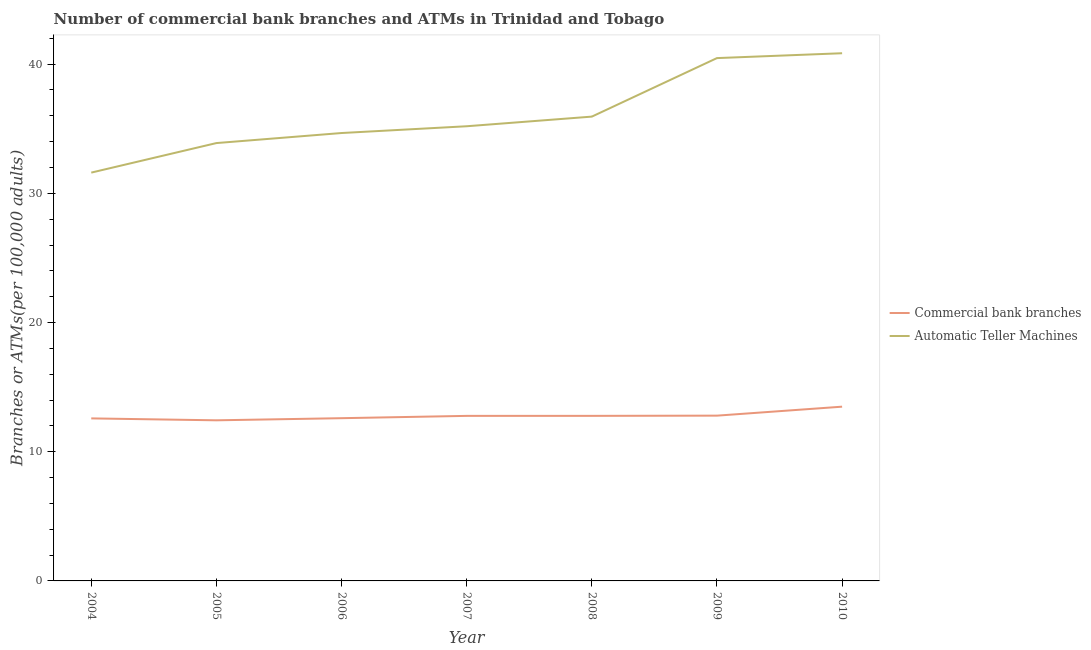How many different coloured lines are there?
Keep it short and to the point. 2. Is the number of lines equal to the number of legend labels?
Keep it short and to the point. Yes. What is the number of commercal bank branches in 2008?
Your answer should be compact. 12.78. Across all years, what is the maximum number of commercal bank branches?
Ensure brevity in your answer.  13.49. Across all years, what is the minimum number of atms?
Provide a short and direct response. 31.6. In which year was the number of atms minimum?
Provide a succinct answer. 2004. What is the total number of commercal bank branches in the graph?
Your answer should be very brief. 89.44. What is the difference between the number of atms in 2007 and that in 2009?
Provide a succinct answer. -5.28. What is the difference between the number of atms in 2005 and the number of commercal bank branches in 2006?
Ensure brevity in your answer.  21.29. What is the average number of commercal bank branches per year?
Make the answer very short. 12.78. In the year 2004, what is the difference between the number of commercal bank branches and number of atms?
Your answer should be compact. -19.02. What is the ratio of the number of commercal bank branches in 2004 to that in 2006?
Provide a succinct answer. 1. Is the number of atms in 2005 less than that in 2009?
Provide a short and direct response. Yes. What is the difference between the highest and the second highest number of commercal bank branches?
Provide a short and direct response. 0.69. What is the difference between the highest and the lowest number of commercal bank branches?
Offer a very short reply. 1.06. In how many years, is the number of atms greater than the average number of atms taken over all years?
Your answer should be very brief. 2. Is the sum of the number of atms in 2008 and 2010 greater than the maximum number of commercal bank branches across all years?
Your answer should be very brief. Yes. Is the number of commercal bank branches strictly less than the number of atms over the years?
Keep it short and to the point. Yes. What is the difference between two consecutive major ticks on the Y-axis?
Your answer should be very brief. 10. Are the values on the major ticks of Y-axis written in scientific E-notation?
Your answer should be very brief. No. Does the graph contain grids?
Offer a terse response. No. How many legend labels are there?
Ensure brevity in your answer.  2. How are the legend labels stacked?
Provide a short and direct response. Vertical. What is the title of the graph?
Keep it short and to the point. Number of commercial bank branches and ATMs in Trinidad and Tobago. Does "Depositors" appear as one of the legend labels in the graph?
Your response must be concise. No. What is the label or title of the X-axis?
Your answer should be compact. Year. What is the label or title of the Y-axis?
Ensure brevity in your answer.  Branches or ATMs(per 100,0 adults). What is the Branches or ATMs(per 100,000 adults) of Commercial bank branches in 2004?
Make the answer very short. 12.58. What is the Branches or ATMs(per 100,000 adults) of Automatic Teller Machines in 2004?
Make the answer very short. 31.6. What is the Branches or ATMs(per 100,000 adults) in Commercial bank branches in 2005?
Your answer should be compact. 12.43. What is the Branches or ATMs(per 100,000 adults) of Automatic Teller Machines in 2005?
Your answer should be compact. 33.89. What is the Branches or ATMs(per 100,000 adults) in Commercial bank branches in 2006?
Your answer should be compact. 12.6. What is the Branches or ATMs(per 100,000 adults) in Automatic Teller Machines in 2006?
Offer a terse response. 34.67. What is the Branches or ATMs(per 100,000 adults) of Commercial bank branches in 2007?
Make the answer very short. 12.77. What is the Branches or ATMs(per 100,000 adults) in Automatic Teller Machines in 2007?
Make the answer very short. 35.19. What is the Branches or ATMs(per 100,000 adults) of Commercial bank branches in 2008?
Offer a very short reply. 12.78. What is the Branches or ATMs(per 100,000 adults) in Automatic Teller Machines in 2008?
Keep it short and to the point. 35.94. What is the Branches or ATMs(per 100,000 adults) in Commercial bank branches in 2009?
Provide a succinct answer. 12.79. What is the Branches or ATMs(per 100,000 adults) of Automatic Teller Machines in 2009?
Give a very brief answer. 40.47. What is the Branches or ATMs(per 100,000 adults) in Commercial bank branches in 2010?
Provide a short and direct response. 13.49. What is the Branches or ATMs(per 100,000 adults) in Automatic Teller Machines in 2010?
Your answer should be very brief. 40.84. Across all years, what is the maximum Branches or ATMs(per 100,000 adults) in Commercial bank branches?
Keep it short and to the point. 13.49. Across all years, what is the maximum Branches or ATMs(per 100,000 adults) in Automatic Teller Machines?
Provide a short and direct response. 40.84. Across all years, what is the minimum Branches or ATMs(per 100,000 adults) in Commercial bank branches?
Offer a terse response. 12.43. Across all years, what is the minimum Branches or ATMs(per 100,000 adults) of Automatic Teller Machines?
Offer a terse response. 31.6. What is the total Branches or ATMs(per 100,000 adults) in Commercial bank branches in the graph?
Your answer should be compact. 89.44. What is the total Branches or ATMs(per 100,000 adults) in Automatic Teller Machines in the graph?
Ensure brevity in your answer.  252.6. What is the difference between the Branches or ATMs(per 100,000 adults) of Commercial bank branches in 2004 and that in 2005?
Your response must be concise. 0.15. What is the difference between the Branches or ATMs(per 100,000 adults) of Automatic Teller Machines in 2004 and that in 2005?
Offer a terse response. -2.29. What is the difference between the Branches or ATMs(per 100,000 adults) of Commercial bank branches in 2004 and that in 2006?
Give a very brief answer. -0.02. What is the difference between the Branches or ATMs(per 100,000 adults) in Automatic Teller Machines in 2004 and that in 2006?
Offer a terse response. -3.06. What is the difference between the Branches or ATMs(per 100,000 adults) in Commercial bank branches in 2004 and that in 2007?
Your response must be concise. -0.2. What is the difference between the Branches or ATMs(per 100,000 adults) of Automatic Teller Machines in 2004 and that in 2007?
Keep it short and to the point. -3.59. What is the difference between the Branches or ATMs(per 100,000 adults) of Commercial bank branches in 2004 and that in 2008?
Make the answer very short. -0.2. What is the difference between the Branches or ATMs(per 100,000 adults) in Automatic Teller Machines in 2004 and that in 2008?
Your response must be concise. -4.33. What is the difference between the Branches or ATMs(per 100,000 adults) of Commercial bank branches in 2004 and that in 2009?
Provide a short and direct response. -0.21. What is the difference between the Branches or ATMs(per 100,000 adults) in Automatic Teller Machines in 2004 and that in 2009?
Offer a very short reply. -8.86. What is the difference between the Branches or ATMs(per 100,000 adults) of Commercial bank branches in 2004 and that in 2010?
Make the answer very short. -0.91. What is the difference between the Branches or ATMs(per 100,000 adults) of Automatic Teller Machines in 2004 and that in 2010?
Your response must be concise. -9.24. What is the difference between the Branches or ATMs(per 100,000 adults) in Commercial bank branches in 2005 and that in 2006?
Provide a short and direct response. -0.16. What is the difference between the Branches or ATMs(per 100,000 adults) in Automatic Teller Machines in 2005 and that in 2006?
Ensure brevity in your answer.  -0.78. What is the difference between the Branches or ATMs(per 100,000 adults) of Commercial bank branches in 2005 and that in 2007?
Offer a terse response. -0.34. What is the difference between the Branches or ATMs(per 100,000 adults) of Automatic Teller Machines in 2005 and that in 2007?
Offer a very short reply. -1.3. What is the difference between the Branches or ATMs(per 100,000 adults) of Commercial bank branches in 2005 and that in 2008?
Your answer should be compact. -0.35. What is the difference between the Branches or ATMs(per 100,000 adults) in Automatic Teller Machines in 2005 and that in 2008?
Give a very brief answer. -2.05. What is the difference between the Branches or ATMs(per 100,000 adults) in Commercial bank branches in 2005 and that in 2009?
Make the answer very short. -0.36. What is the difference between the Branches or ATMs(per 100,000 adults) in Automatic Teller Machines in 2005 and that in 2009?
Give a very brief answer. -6.58. What is the difference between the Branches or ATMs(per 100,000 adults) in Commercial bank branches in 2005 and that in 2010?
Your response must be concise. -1.06. What is the difference between the Branches or ATMs(per 100,000 adults) in Automatic Teller Machines in 2005 and that in 2010?
Ensure brevity in your answer.  -6.95. What is the difference between the Branches or ATMs(per 100,000 adults) in Commercial bank branches in 2006 and that in 2007?
Ensure brevity in your answer.  -0.18. What is the difference between the Branches or ATMs(per 100,000 adults) of Automatic Teller Machines in 2006 and that in 2007?
Ensure brevity in your answer.  -0.52. What is the difference between the Branches or ATMs(per 100,000 adults) in Commercial bank branches in 2006 and that in 2008?
Your answer should be compact. -0.18. What is the difference between the Branches or ATMs(per 100,000 adults) in Automatic Teller Machines in 2006 and that in 2008?
Provide a succinct answer. -1.27. What is the difference between the Branches or ATMs(per 100,000 adults) of Commercial bank branches in 2006 and that in 2009?
Offer a very short reply. -0.2. What is the difference between the Branches or ATMs(per 100,000 adults) of Automatic Teller Machines in 2006 and that in 2009?
Provide a short and direct response. -5.8. What is the difference between the Branches or ATMs(per 100,000 adults) of Commercial bank branches in 2006 and that in 2010?
Offer a very short reply. -0.89. What is the difference between the Branches or ATMs(per 100,000 adults) in Automatic Teller Machines in 2006 and that in 2010?
Offer a terse response. -6.18. What is the difference between the Branches or ATMs(per 100,000 adults) in Commercial bank branches in 2007 and that in 2008?
Provide a short and direct response. -0. What is the difference between the Branches or ATMs(per 100,000 adults) in Automatic Teller Machines in 2007 and that in 2008?
Your answer should be very brief. -0.75. What is the difference between the Branches or ATMs(per 100,000 adults) of Commercial bank branches in 2007 and that in 2009?
Keep it short and to the point. -0.02. What is the difference between the Branches or ATMs(per 100,000 adults) in Automatic Teller Machines in 2007 and that in 2009?
Provide a succinct answer. -5.28. What is the difference between the Branches or ATMs(per 100,000 adults) in Commercial bank branches in 2007 and that in 2010?
Provide a succinct answer. -0.71. What is the difference between the Branches or ATMs(per 100,000 adults) in Automatic Teller Machines in 2007 and that in 2010?
Your response must be concise. -5.65. What is the difference between the Branches or ATMs(per 100,000 adults) in Commercial bank branches in 2008 and that in 2009?
Your answer should be compact. -0.02. What is the difference between the Branches or ATMs(per 100,000 adults) of Automatic Teller Machines in 2008 and that in 2009?
Give a very brief answer. -4.53. What is the difference between the Branches or ATMs(per 100,000 adults) in Commercial bank branches in 2008 and that in 2010?
Your answer should be very brief. -0.71. What is the difference between the Branches or ATMs(per 100,000 adults) of Automatic Teller Machines in 2008 and that in 2010?
Your answer should be compact. -4.91. What is the difference between the Branches or ATMs(per 100,000 adults) in Commercial bank branches in 2009 and that in 2010?
Your answer should be very brief. -0.69. What is the difference between the Branches or ATMs(per 100,000 adults) of Automatic Teller Machines in 2009 and that in 2010?
Give a very brief answer. -0.38. What is the difference between the Branches or ATMs(per 100,000 adults) of Commercial bank branches in 2004 and the Branches or ATMs(per 100,000 adults) of Automatic Teller Machines in 2005?
Your answer should be compact. -21.31. What is the difference between the Branches or ATMs(per 100,000 adults) in Commercial bank branches in 2004 and the Branches or ATMs(per 100,000 adults) in Automatic Teller Machines in 2006?
Provide a succinct answer. -22.09. What is the difference between the Branches or ATMs(per 100,000 adults) of Commercial bank branches in 2004 and the Branches or ATMs(per 100,000 adults) of Automatic Teller Machines in 2007?
Offer a very short reply. -22.61. What is the difference between the Branches or ATMs(per 100,000 adults) of Commercial bank branches in 2004 and the Branches or ATMs(per 100,000 adults) of Automatic Teller Machines in 2008?
Give a very brief answer. -23.36. What is the difference between the Branches or ATMs(per 100,000 adults) in Commercial bank branches in 2004 and the Branches or ATMs(per 100,000 adults) in Automatic Teller Machines in 2009?
Offer a very short reply. -27.89. What is the difference between the Branches or ATMs(per 100,000 adults) of Commercial bank branches in 2004 and the Branches or ATMs(per 100,000 adults) of Automatic Teller Machines in 2010?
Your answer should be very brief. -28.26. What is the difference between the Branches or ATMs(per 100,000 adults) in Commercial bank branches in 2005 and the Branches or ATMs(per 100,000 adults) in Automatic Teller Machines in 2006?
Your answer should be very brief. -22.24. What is the difference between the Branches or ATMs(per 100,000 adults) in Commercial bank branches in 2005 and the Branches or ATMs(per 100,000 adults) in Automatic Teller Machines in 2007?
Offer a terse response. -22.76. What is the difference between the Branches or ATMs(per 100,000 adults) of Commercial bank branches in 2005 and the Branches or ATMs(per 100,000 adults) of Automatic Teller Machines in 2008?
Your response must be concise. -23.51. What is the difference between the Branches or ATMs(per 100,000 adults) of Commercial bank branches in 2005 and the Branches or ATMs(per 100,000 adults) of Automatic Teller Machines in 2009?
Your answer should be very brief. -28.04. What is the difference between the Branches or ATMs(per 100,000 adults) of Commercial bank branches in 2005 and the Branches or ATMs(per 100,000 adults) of Automatic Teller Machines in 2010?
Keep it short and to the point. -28.41. What is the difference between the Branches or ATMs(per 100,000 adults) in Commercial bank branches in 2006 and the Branches or ATMs(per 100,000 adults) in Automatic Teller Machines in 2007?
Provide a succinct answer. -22.6. What is the difference between the Branches or ATMs(per 100,000 adults) in Commercial bank branches in 2006 and the Branches or ATMs(per 100,000 adults) in Automatic Teller Machines in 2008?
Provide a succinct answer. -23.34. What is the difference between the Branches or ATMs(per 100,000 adults) of Commercial bank branches in 2006 and the Branches or ATMs(per 100,000 adults) of Automatic Teller Machines in 2009?
Offer a very short reply. -27.87. What is the difference between the Branches or ATMs(per 100,000 adults) in Commercial bank branches in 2006 and the Branches or ATMs(per 100,000 adults) in Automatic Teller Machines in 2010?
Provide a succinct answer. -28.25. What is the difference between the Branches or ATMs(per 100,000 adults) in Commercial bank branches in 2007 and the Branches or ATMs(per 100,000 adults) in Automatic Teller Machines in 2008?
Ensure brevity in your answer.  -23.16. What is the difference between the Branches or ATMs(per 100,000 adults) in Commercial bank branches in 2007 and the Branches or ATMs(per 100,000 adults) in Automatic Teller Machines in 2009?
Make the answer very short. -27.69. What is the difference between the Branches or ATMs(per 100,000 adults) in Commercial bank branches in 2007 and the Branches or ATMs(per 100,000 adults) in Automatic Teller Machines in 2010?
Your answer should be compact. -28.07. What is the difference between the Branches or ATMs(per 100,000 adults) in Commercial bank branches in 2008 and the Branches or ATMs(per 100,000 adults) in Automatic Teller Machines in 2009?
Give a very brief answer. -27.69. What is the difference between the Branches or ATMs(per 100,000 adults) in Commercial bank branches in 2008 and the Branches or ATMs(per 100,000 adults) in Automatic Teller Machines in 2010?
Provide a succinct answer. -28.07. What is the difference between the Branches or ATMs(per 100,000 adults) of Commercial bank branches in 2009 and the Branches or ATMs(per 100,000 adults) of Automatic Teller Machines in 2010?
Offer a terse response. -28.05. What is the average Branches or ATMs(per 100,000 adults) in Commercial bank branches per year?
Your response must be concise. 12.78. What is the average Branches or ATMs(per 100,000 adults) in Automatic Teller Machines per year?
Your answer should be compact. 36.09. In the year 2004, what is the difference between the Branches or ATMs(per 100,000 adults) in Commercial bank branches and Branches or ATMs(per 100,000 adults) in Automatic Teller Machines?
Your answer should be very brief. -19.02. In the year 2005, what is the difference between the Branches or ATMs(per 100,000 adults) of Commercial bank branches and Branches or ATMs(per 100,000 adults) of Automatic Teller Machines?
Provide a short and direct response. -21.46. In the year 2006, what is the difference between the Branches or ATMs(per 100,000 adults) of Commercial bank branches and Branches or ATMs(per 100,000 adults) of Automatic Teller Machines?
Offer a terse response. -22.07. In the year 2007, what is the difference between the Branches or ATMs(per 100,000 adults) of Commercial bank branches and Branches or ATMs(per 100,000 adults) of Automatic Teller Machines?
Offer a very short reply. -22.42. In the year 2008, what is the difference between the Branches or ATMs(per 100,000 adults) of Commercial bank branches and Branches or ATMs(per 100,000 adults) of Automatic Teller Machines?
Offer a very short reply. -23.16. In the year 2009, what is the difference between the Branches or ATMs(per 100,000 adults) in Commercial bank branches and Branches or ATMs(per 100,000 adults) in Automatic Teller Machines?
Offer a very short reply. -27.67. In the year 2010, what is the difference between the Branches or ATMs(per 100,000 adults) of Commercial bank branches and Branches or ATMs(per 100,000 adults) of Automatic Teller Machines?
Keep it short and to the point. -27.36. What is the ratio of the Branches or ATMs(per 100,000 adults) of Commercial bank branches in 2004 to that in 2005?
Make the answer very short. 1.01. What is the ratio of the Branches or ATMs(per 100,000 adults) in Automatic Teller Machines in 2004 to that in 2005?
Offer a terse response. 0.93. What is the ratio of the Branches or ATMs(per 100,000 adults) of Automatic Teller Machines in 2004 to that in 2006?
Make the answer very short. 0.91. What is the ratio of the Branches or ATMs(per 100,000 adults) in Commercial bank branches in 2004 to that in 2007?
Ensure brevity in your answer.  0.98. What is the ratio of the Branches or ATMs(per 100,000 adults) in Automatic Teller Machines in 2004 to that in 2007?
Keep it short and to the point. 0.9. What is the ratio of the Branches or ATMs(per 100,000 adults) in Commercial bank branches in 2004 to that in 2008?
Provide a succinct answer. 0.98. What is the ratio of the Branches or ATMs(per 100,000 adults) of Automatic Teller Machines in 2004 to that in 2008?
Your response must be concise. 0.88. What is the ratio of the Branches or ATMs(per 100,000 adults) in Commercial bank branches in 2004 to that in 2009?
Provide a succinct answer. 0.98. What is the ratio of the Branches or ATMs(per 100,000 adults) in Automatic Teller Machines in 2004 to that in 2009?
Provide a succinct answer. 0.78. What is the ratio of the Branches or ATMs(per 100,000 adults) in Commercial bank branches in 2004 to that in 2010?
Offer a very short reply. 0.93. What is the ratio of the Branches or ATMs(per 100,000 adults) of Automatic Teller Machines in 2004 to that in 2010?
Keep it short and to the point. 0.77. What is the ratio of the Branches or ATMs(per 100,000 adults) in Commercial bank branches in 2005 to that in 2006?
Provide a short and direct response. 0.99. What is the ratio of the Branches or ATMs(per 100,000 adults) in Automatic Teller Machines in 2005 to that in 2006?
Your answer should be compact. 0.98. What is the ratio of the Branches or ATMs(per 100,000 adults) of Commercial bank branches in 2005 to that in 2007?
Your answer should be very brief. 0.97. What is the ratio of the Branches or ATMs(per 100,000 adults) in Commercial bank branches in 2005 to that in 2008?
Offer a very short reply. 0.97. What is the ratio of the Branches or ATMs(per 100,000 adults) in Automatic Teller Machines in 2005 to that in 2008?
Provide a short and direct response. 0.94. What is the ratio of the Branches or ATMs(per 100,000 adults) in Commercial bank branches in 2005 to that in 2009?
Your answer should be very brief. 0.97. What is the ratio of the Branches or ATMs(per 100,000 adults) in Automatic Teller Machines in 2005 to that in 2009?
Keep it short and to the point. 0.84. What is the ratio of the Branches or ATMs(per 100,000 adults) of Commercial bank branches in 2005 to that in 2010?
Your answer should be very brief. 0.92. What is the ratio of the Branches or ATMs(per 100,000 adults) in Automatic Teller Machines in 2005 to that in 2010?
Your answer should be compact. 0.83. What is the ratio of the Branches or ATMs(per 100,000 adults) in Automatic Teller Machines in 2006 to that in 2007?
Give a very brief answer. 0.99. What is the ratio of the Branches or ATMs(per 100,000 adults) in Commercial bank branches in 2006 to that in 2008?
Offer a terse response. 0.99. What is the ratio of the Branches or ATMs(per 100,000 adults) of Automatic Teller Machines in 2006 to that in 2008?
Your response must be concise. 0.96. What is the ratio of the Branches or ATMs(per 100,000 adults) in Commercial bank branches in 2006 to that in 2009?
Your answer should be compact. 0.98. What is the ratio of the Branches or ATMs(per 100,000 adults) of Automatic Teller Machines in 2006 to that in 2009?
Give a very brief answer. 0.86. What is the ratio of the Branches or ATMs(per 100,000 adults) of Commercial bank branches in 2006 to that in 2010?
Your response must be concise. 0.93. What is the ratio of the Branches or ATMs(per 100,000 adults) in Automatic Teller Machines in 2006 to that in 2010?
Your response must be concise. 0.85. What is the ratio of the Branches or ATMs(per 100,000 adults) in Commercial bank branches in 2007 to that in 2008?
Ensure brevity in your answer.  1. What is the ratio of the Branches or ATMs(per 100,000 adults) in Automatic Teller Machines in 2007 to that in 2008?
Your response must be concise. 0.98. What is the ratio of the Branches or ATMs(per 100,000 adults) of Commercial bank branches in 2007 to that in 2009?
Your answer should be very brief. 1. What is the ratio of the Branches or ATMs(per 100,000 adults) of Automatic Teller Machines in 2007 to that in 2009?
Your response must be concise. 0.87. What is the ratio of the Branches or ATMs(per 100,000 adults) in Commercial bank branches in 2007 to that in 2010?
Make the answer very short. 0.95. What is the ratio of the Branches or ATMs(per 100,000 adults) of Automatic Teller Machines in 2007 to that in 2010?
Make the answer very short. 0.86. What is the ratio of the Branches or ATMs(per 100,000 adults) in Commercial bank branches in 2008 to that in 2009?
Provide a succinct answer. 1. What is the ratio of the Branches or ATMs(per 100,000 adults) of Automatic Teller Machines in 2008 to that in 2009?
Provide a succinct answer. 0.89. What is the ratio of the Branches or ATMs(per 100,000 adults) of Commercial bank branches in 2008 to that in 2010?
Your answer should be very brief. 0.95. What is the ratio of the Branches or ATMs(per 100,000 adults) in Automatic Teller Machines in 2008 to that in 2010?
Your answer should be very brief. 0.88. What is the ratio of the Branches or ATMs(per 100,000 adults) of Commercial bank branches in 2009 to that in 2010?
Your answer should be compact. 0.95. What is the difference between the highest and the second highest Branches or ATMs(per 100,000 adults) of Commercial bank branches?
Make the answer very short. 0.69. What is the difference between the highest and the second highest Branches or ATMs(per 100,000 adults) in Automatic Teller Machines?
Your answer should be compact. 0.38. What is the difference between the highest and the lowest Branches or ATMs(per 100,000 adults) in Commercial bank branches?
Offer a very short reply. 1.06. What is the difference between the highest and the lowest Branches or ATMs(per 100,000 adults) of Automatic Teller Machines?
Offer a terse response. 9.24. 